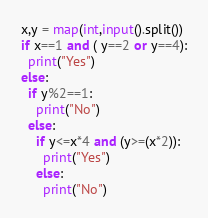Convert code to text. <code><loc_0><loc_0><loc_500><loc_500><_Python_>x,y = map(int,input().split())
if x==1 and ( y==2 or y==4):
  print("Yes")
else:
  if y%2==1:
    print("No")
  else:
    if y<=x*4 and (y>=(x*2)):
      print("Yes")
    else:
      print("No")</code> 